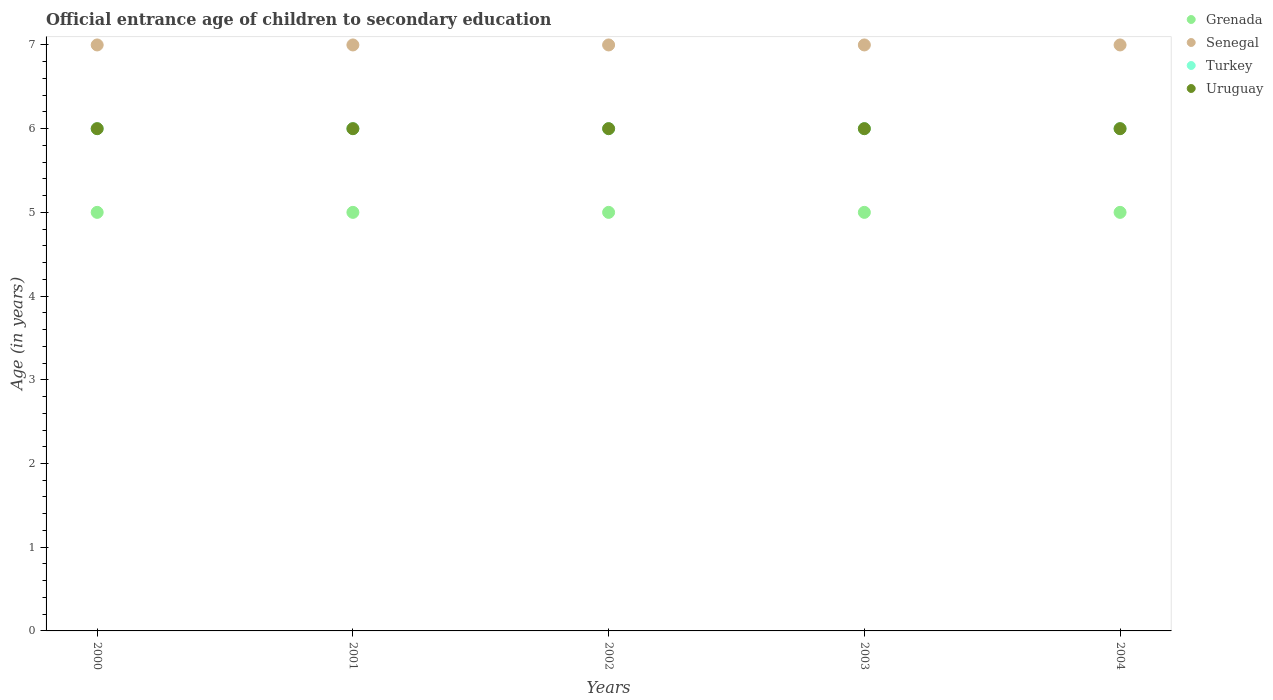Is the number of dotlines equal to the number of legend labels?
Offer a very short reply. Yes. What is the secondary school starting age of children in Grenada in 2004?
Provide a short and direct response. 5. Across all years, what is the maximum secondary school starting age of children in Senegal?
Offer a terse response. 7. In which year was the secondary school starting age of children in Turkey maximum?
Offer a terse response. 2000. What is the total secondary school starting age of children in Senegal in the graph?
Provide a short and direct response. 35. What is the difference between the secondary school starting age of children in Turkey in 2002 and the secondary school starting age of children in Uruguay in 2001?
Make the answer very short. 0. What is the average secondary school starting age of children in Grenada per year?
Provide a short and direct response. 5. In the year 2001, what is the difference between the secondary school starting age of children in Senegal and secondary school starting age of children in Turkey?
Your answer should be compact. 1. In how many years, is the secondary school starting age of children in Uruguay greater than 4 years?
Provide a short and direct response. 5. Is the secondary school starting age of children in Turkey in 2002 less than that in 2003?
Give a very brief answer. No. In how many years, is the secondary school starting age of children in Uruguay greater than the average secondary school starting age of children in Uruguay taken over all years?
Keep it short and to the point. 0. Is the sum of the secondary school starting age of children in Uruguay in 2001 and 2002 greater than the maximum secondary school starting age of children in Grenada across all years?
Your answer should be compact. Yes. Does the secondary school starting age of children in Senegal monotonically increase over the years?
Your answer should be compact. No. Is the secondary school starting age of children in Senegal strictly greater than the secondary school starting age of children in Uruguay over the years?
Offer a terse response. Yes. What is the difference between two consecutive major ticks on the Y-axis?
Keep it short and to the point. 1. Does the graph contain grids?
Your answer should be very brief. No. What is the title of the graph?
Offer a terse response. Official entrance age of children to secondary education. What is the label or title of the X-axis?
Offer a very short reply. Years. What is the label or title of the Y-axis?
Give a very brief answer. Age (in years). What is the Age (in years) of Grenada in 2000?
Your answer should be very brief. 5. What is the Age (in years) in Senegal in 2000?
Offer a very short reply. 7. What is the Age (in years) of Uruguay in 2000?
Provide a short and direct response. 6. What is the Age (in years) in Grenada in 2001?
Ensure brevity in your answer.  5. What is the Age (in years) of Turkey in 2001?
Keep it short and to the point. 6. What is the Age (in years) of Grenada in 2002?
Provide a short and direct response. 5. What is the Age (in years) in Turkey in 2002?
Your answer should be compact. 6. What is the Age (in years) in Uruguay in 2002?
Your response must be concise. 6. What is the Age (in years) of Senegal in 2003?
Keep it short and to the point. 7. What is the Age (in years) of Senegal in 2004?
Make the answer very short. 7. What is the Age (in years) of Turkey in 2004?
Your answer should be very brief. 6. What is the Age (in years) of Uruguay in 2004?
Your answer should be compact. 6. Across all years, what is the maximum Age (in years) of Grenada?
Provide a short and direct response. 5. Across all years, what is the maximum Age (in years) of Senegal?
Provide a succinct answer. 7. Across all years, what is the maximum Age (in years) in Uruguay?
Provide a short and direct response. 6. Across all years, what is the minimum Age (in years) in Grenada?
Make the answer very short. 5. What is the total Age (in years) in Senegal in the graph?
Offer a terse response. 35. What is the total Age (in years) of Uruguay in the graph?
Your response must be concise. 30. What is the difference between the Age (in years) of Senegal in 2000 and that in 2001?
Ensure brevity in your answer.  0. What is the difference between the Age (in years) in Uruguay in 2000 and that in 2001?
Keep it short and to the point. 0. What is the difference between the Age (in years) in Grenada in 2000 and that in 2002?
Your answer should be compact. 0. What is the difference between the Age (in years) in Turkey in 2000 and that in 2002?
Make the answer very short. 0. What is the difference between the Age (in years) in Grenada in 2000 and that in 2003?
Your response must be concise. 0. What is the difference between the Age (in years) in Senegal in 2000 and that in 2003?
Your response must be concise. 0. What is the difference between the Age (in years) of Senegal in 2000 and that in 2004?
Ensure brevity in your answer.  0. What is the difference between the Age (in years) in Grenada in 2001 and that in 2002?
Provide a short and direct response. 0. What is the difference between the Age (in years) in Senegal in 2001 and that in 2002?
Offer a very short reply. 0. What is the difference between the Age (in years) in Turkey in 2001 and that in 2002?
Your response must be concise. 0. What is the difference between the Age (in years) in Grenada in 2001 and that in 2004?
Provide a short and direct response. 0. What is the difference between the Age (in years) of Uruguay in 2001 and that in 2004?
Your answer should be very brief. 0. What is the difference between the Age (in years) in Senegal in 2002 and that in 2003?
Give a very brief answer. 0. What is the difference between the Age (in years) of Uruguay in 2002 and that in 2003?
Provide a succinct answer. 0. What is the difference between the Age (in years) in Senegal in 2002 and that in 2004?
Your answer should be very brief. 0. What is the difference between the Age (in years) in Grenada in 2003 and that in 2004?
Give a very brief answer. 0. What is the difference between the Age (in years) in Grenada in 2000 and the Age (in years) in Turkey in 2001?
Your answer should be very brief. -1. What is the difference between the Age (in years) in Grenada in 2000 and the Age (in years) in Uruguay in 2001?
Offer a very short reply. -1. What is the difference between the Age (in years) of Senegal in 2000 and the Age (in years) of Uruguay in 2001?
Provide a succinct answer. 1. What is the difference between the Age (in years) in Grenada in 2000 and the Age (in years) in Uruguay in 2002?
Offer a terse response. -1. What is the difference between the Age (in years) in Senegal in 2000 and the Age (in years) in Turkey in 2002?
Keep it short and to the point. 1. What is the difference between the Age (in years) of Turkey in 2000 and the Age (in years) of Uruguay in 2002?
Your response must be concise. 0. What is the difference between the Age (in years) in Grenada in 2000 and the Age (in years) in Senegal in 2003?
Your response must be concise. -2. What is the difference between the Age (in years) of Grenada in 2000 and the Age (in years) of Uruguay in 2003?
Provide a succinct answer. -1. What is the difference between the Age (in years) in Senegal in 2000 and the Age (in years) in Turkey in 2003?
Ensure brevity in your answer.  1. What is the difference between the Age (in years) in Senegal in 2000 and the Age (in years) in Uruguay in 2003?
Your answer should be very brief. 1. What is the difference between the Age (in years) of Grenada in 2000 and the Age (in years) of Senegal in 2004?
Provide a short and direct response. -2. What is the difference between the Age (in years) in Grenada in 2000 and the Age (in years) in Uruguay in 2004?
Provide a short and direct response. -1. What is the difference between the Age (in years) in Senegal in 2000 and the Age (in years) in Uruguay in 2004?
Give a very brief answer. 1. What is the difference between the Age (in years) in Turkey in 2000 and the Age (in years) in Uruguay in 2004?
Your response must be concise. 0. What is the difference between the Age (in years) of Grenada in 2001 and the Age (in years) of Senegal in 2002?
Your answer should be compact. -2. What is the difference between the Age (in years) of Grenada in 2001 and the Age (in years) of Turkey in 2002?
Your response must be concise. -1. What is the difference between the Age (in years) of Grenada in 2001 and the Age (in years) of Uruguay in 2002?
Ensure brevity in your answer.  -1. What is the difference between the Age (in years) of Turkey in 2001 and the Age (in years) of Uruguay in 2002?
Your answer should be very brief. 0. What is the difference between the Age (in years) of Senegal in 2001 and the Age (in years) of Uruguay in 2003?
Your response must be concise. 1. What is the difference between the Age (in years) of Turkey in 2001 and the Age (in years) of Uruguay in 2003?
Give a very brief answer. 0. What is the difference between the Age (in years) in Grenada in 2001 and the Age (in years) in Senegal in 2004?
Keep it short and to the point. -2. What is the difference between the Age (in years) in Grenada in 2001 and the Age (in years) in Turkey in 2004?
Your answer should be very brief. -1. What is the difference between the Age (in years) of Senegal in 2001 and the Age (in years) of Turkey in 2004?
Provide a succinct answer. 1. What is the difference between the Age (in years) in Senegal in 2001 and the Age (in years) in Uruguay in 2004?
Your answer should be compact. 1. What is the difference between the Age (in years) of Grenada in 2002 and the Age (in years) of Senegal in 2003?
Ensure brevity in your answer.  -2. What is the difference between the Age (in years) in Grenada in 2002 and the Age (in years) in Turkey in 2003?
Your answer should be compact. -1. What is the difference between the Age (in years) of Grenada in 2002 and the Age (in years) of Uruguay in 2003?
Your answer should be compact. -1. What is the difference between the Age (in years) in Senegal in 2002 and the Age (in years) in Turkey in 2003?
Your answer should be compact. 1. What is the difference between the Age (in years) in Turkey in 2002 and the Age (in years) in Uruguay in 2003?
Keep it short and to the point. 0. What is the difference between the Age (in years) of Senegal in 2002 and the Age (in years) of Turkey in 2004?
Offer a very short reply. 1. What is the difference between the Age (in years) in Senegal in 2002 and the Age (in years) in Uruguay in 2004?
Make the answer very short. 1. What is the difference between the Age (in years) in Turkey in 2002 and the Age (in years) in Uruguay in 2004?
Offer a very short reply. 0. What is the difference between the Age (in years) in Grenada in 2003 and the Age (in years) in Senegal in 2004?
Provide a short and direct response. -2. What is the difference between the Age (in years) in Grenada in 2003 and the Age (in years) in Uruguay in 2004?
Provide a succinct answer. -1. What is the difference between the Age (in years) in Senegal in 2003 and the Age (in years) in Turkey in 2004?
Provide a short and direct response. 1. What is the difference between the Age (in years) of Senegal in 2003 and the Age (in years) of Uruguay in 2004?
Make the answer very short. 1. What is the difference between the Age (in years) in Turkey in 2003 and the Age (in years) in Uruguay in 2004?
Offer a terse response. 0. What is the average Age (in years) in Grenada per year?
Ensure brevity in your answer.  5. What is the average Age (in years) of Senegal per year?
Provide a short and direct response. 7. What is the average Age (in years) of Turkey per year?
Your answer should be compact. 6. In the year 2000, what is the difference between the Age (in years) in Grenada and Age (in years) in Senegal?
Your response must be concise. -2. In the year 2000, what is the difference between the Age (in years) in Grenada and Age (in years) in Uruguay?
Your answer should be very brief. -1. In the year 2001, what is the difference between the Age (in years) in Grenada and Age (in years) in Turkey?
Make the answer very short. -1. In the year 2001, what is the difference between the Age (in years) of Grenada and Age (in years) of Uruguay?
Keep it short and to the point. -1. In the year 2001, what is the difference between the Age (in years) of Senegal and Age (in years) of Turkey?
Give a very brief answer. 1. In the year 2002, what is the difference between the Age (in years) in Grenada and Age (in years) in Senegal?
Offer a very short reply. -2. In the year 2002, what is the difference between the Age (in years) in Senegal and Age (in years) in Turkey?
Provide a short and direct response. 1. In the year 2002, what is the difference between the Age (in years) of Senegal and Age (in years) of Uruguay?
Make the answer very short. 1. In the year 2003, what is the difference between the Age (in years) in Grenada and Age (in years) in Senegal?
Give a very brief answer. -2. In the year 2003, what is the difference between the Age (in years) in Grenada and Age (in years) in Turkey?
Keep it short and to the point. -1. In the year 2004, what is the difference between the Age (in years) of Grenada and Age (in years) of Senegal?
Offer a very short reply. -2. In the year 2004, what is the difference between the Age (in years) in Grenada and Age (in years) in Turkey?
Your answer should be very brief. -1. In the year 2004, what is the difference between the Age (in years) of Senegal and Age (in years) of Turkey?
Offer a terse response. 1. In the year 2004, what is the difference between the Age (in years) in Senegal and Age (in years) in Uruguay?
Offer a very short reply. 1. In the year 2004, what is the difference between the Age (in years) of Turkey and Age (in years) of Uruguay?
Ensure brevity in your answer.  0. What is the ratio of the Age (in years) of Grenada in 2000 to that in 2001?
Make the answer very short. 1. What is the ratio of the Age (in years) of Senegal in 2000 to that in 2001?
Your answer should be compact. 1. What is the ratio of the Age (in years) in Uruguay in 2000 to that in 2001?
Offer a very short reply. 1. What is the ratio of the Age (in years) in Grenada in 2000 to that in 2002?
Your response must be concise. 1. What is the ratio of the Age (in years) of Turkey in 2000 to that in 2002?
Offer a very short reply. 1. What is the ratio of the Age (in years) in Grenada in 2000 to that in 2003?
Offer a very short reply. 1. What is the ratio of the Age (in years) in Turkey in 2000 to that in 2003?
Your response must be concise. 1. What is the ratio of the Age (in years) in Turkey in 2000 to that in 2004?
Keep it short and to the point. 1. What is the ratio of the Age (in years) in Uruguay in 2001 to that in 2002?
Provide a succinct answer. 1. What is the ratio of the Age (in years) in Grenada in 2001 to that in 2003?
Give a very brief answer. 1. What is the ratio of the Age (in years) of Turkey in 2001 to that in 2003?
Provide a succinct answer. 1. What is the ratio of the Age (in years) in Uruguay in 2001 to that in 2003?
Offer a very short reply. 1. What is the ratio of the Age (in years) of Grenada in 2001 to that in 2004?
Give a very brief answer. 1. What is the ratio of the Age (in years) in Senegal in 2001 to that in 2004?
Your answer should be compact. 1. What is the ratio of the Age (in years) in Turkey in 2001 to that in 2004?
Offer a very short reply. 1. What is the ratio of the Age (in years) in Grenada in 2002 to that in 2003?
Offer a terse response. 1. What is the ratio of the Age (in years) of Turkey in 2002 to that in 2003?
Offer a terse response. 1. What is the ratio of the Age (in years) in Uruguay in 2002 to that in 2003?
Your response must be concise. 1. What is the ratio of the Age (in years) of Senegal in 2002 to that in 2004?
Ensure brevity in your answer.  1. What is the ratio of the Age (in years) in Turkey in 2002 to that in 2004?
Give a very brief answer. 1. What is the ratio of the Age (in years) in Grenada in 2003 to that in 2004?
Your answer should be very brief. 1. What is the ratio of the Age (in years) in Senegal in 2003 to that in 2004?
Give a very brief answer. 1. What is the ratio of the Age (in years) in Turkey in 2003 to that in 2004?
Give a very brief answer. 1. What is the difference between the highest and the lowest Age (in years) in Grenada?
Provide a succinct answer. 0. What is the difference between the highest and the lowest Age (in years) in Senegal?
Your response must be concise. 0. 